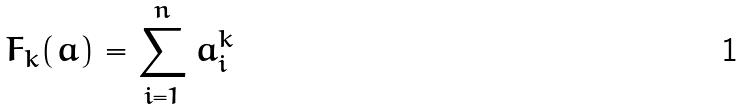<formula> <loc_0><loc_0><loc_500><loc_500>F _ { k } ( a ) = \sum _ { i = 1 } ^ { n } a _ { i } ^ { k }</formula> 